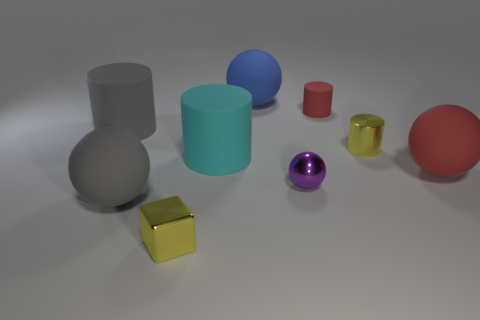Add 1 big purple blocks. How many objects exist? 10 Subtract all cubes. How many objects are left? 8 Add 2 small purple cylinders. How many small purple cylinders exist? 2 Subtract 0 blue cylinders. How many objects are left? 9 Subtract all blue rubber cylinders. Subtract all tiny spheres. How many objects are left? 8 Add 7 purple metallic objects. How many purple metallic objects are left? 8 